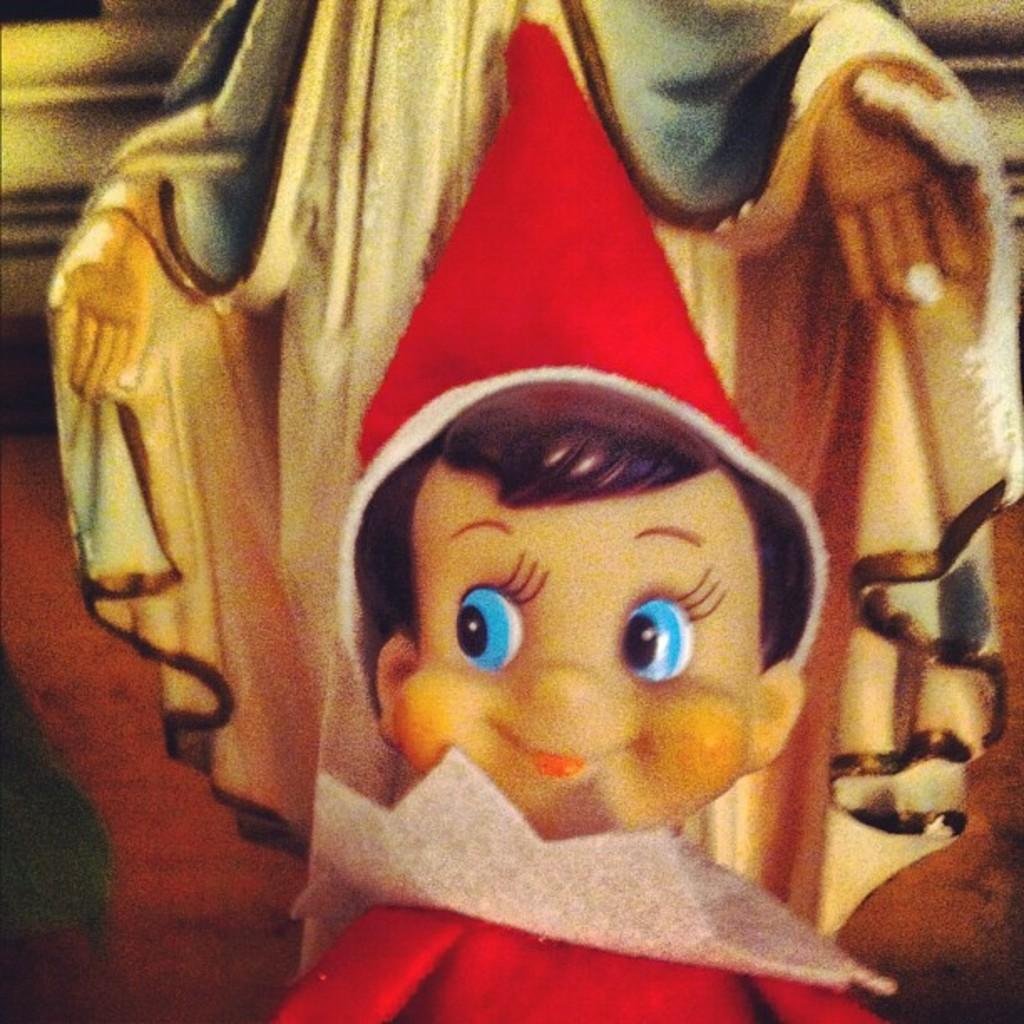What object can be seen in the image? There is a toy in the image. What is the toy wearing? The toy is wearing a red dress. What can be seen in the background of the image? There is a statue in the background of the image. What type of stitch is used to sew the toy's red dress in the image? There is no information about the stitch used to sew the toy's red dress in the image. 